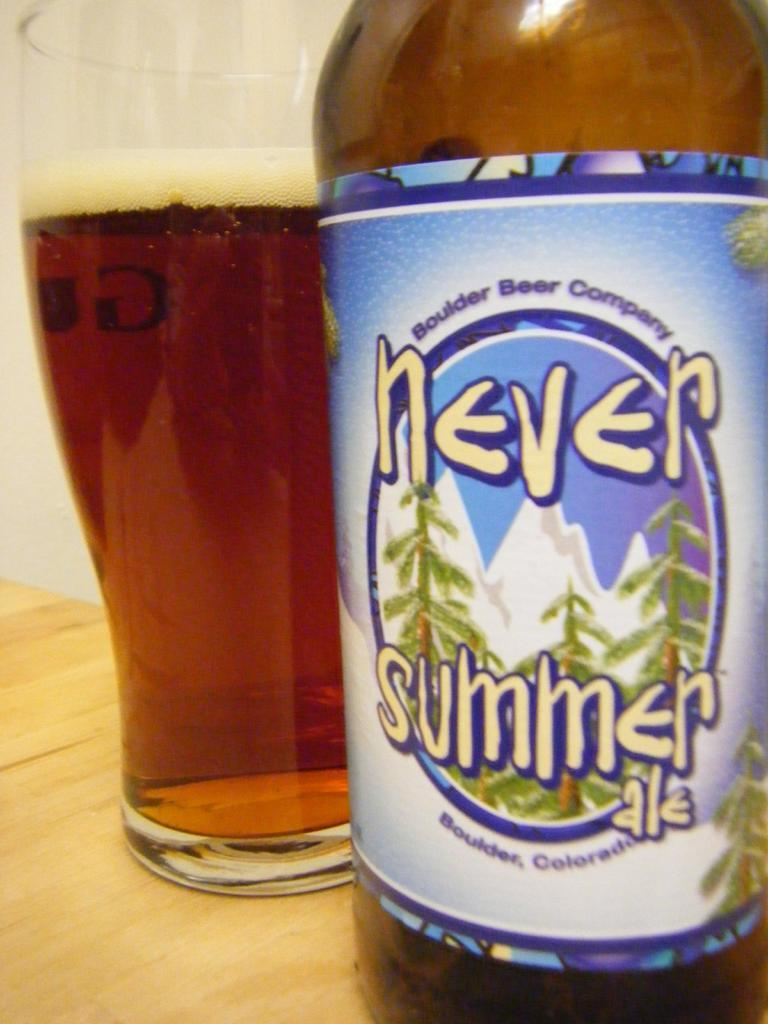<image>
Write a terse but informative summary of the picture. A pint glass of beer sits next to a bottle of Never Summer ale. 